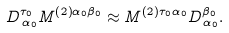<formula> <loc_0><loc_0><loc_500><loc_500>D _ { \, \alpha _ { 0 } } ^ { \tau _ { 0 } } M ^ { \left ( 2 \right ) \alpha _ { 0 } \beta _ { 0 } } \approx M ^ { \left ( 2 \right ) \tau _ { 0 } \alpha _ { 0 } } D _ { \, \alpha _ { 0 } } ^ { \beta _ { 0 } } .</formula> 